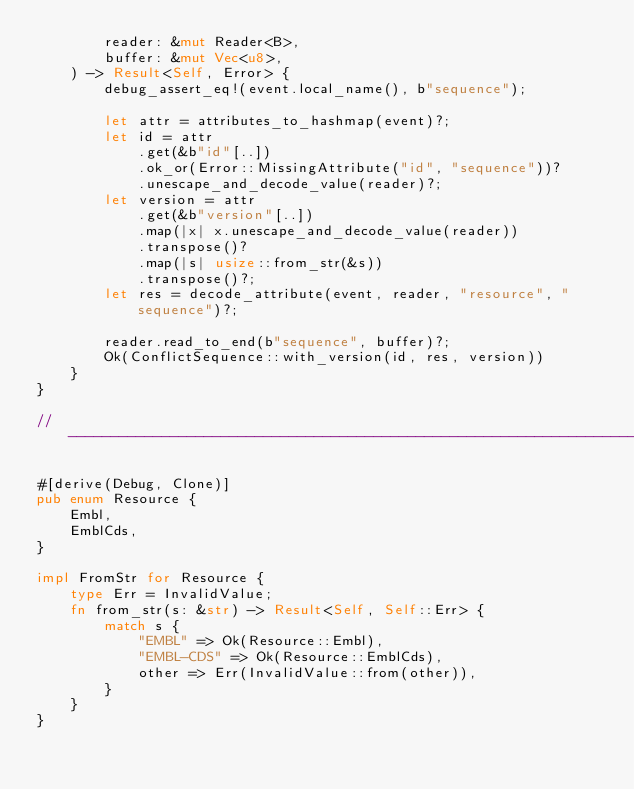Convert code to text. <code><loc_0><loc_0><loc_500><loc_500><_Rust_>        reader: &mut Reader<B>,
        buffer: &mut Vec<u8>,
    ) -> Result<Self, Error> {
        debug_assert_eq!(event.local_name(), b"sequence");

        let attr = attributes_to_hashmap(event)?;
        let id = attr
            .get(&b"id"[..])
            .ok_or(Error::MissingAttribute("id", "sequence"))?
            .unescape_and_decode_value(reader)?;
        let version = attr
            .get(&b"version"[..])
            .map(|x| x.unescape_and_decode_value(reader))
            .transpose()?
            .map(|s| usize::from_str(&s))
            .transpose()?;
        let res = decode_attribute(event, reader, "resource", "sequence")?;

        reader.read_to_end(b"sequence", buffer)?;
        Ok(ConflictSequence::with_version(id, res, version))
    }
}

// ---------------------------------------------------------------------------

#[derive(Debug, Clone)]
pub enum Resource {
    Embl,
    EmblCds,
}

impl FromStr for Resource {
    type Err = InvalidValue;
    fn from_str(s: &str) -> Result<Self, Self::Err> {
        match s {
            "EMBL" => Ok(Resource::Embl),
            "EMBL-CDS" => Ok(Resource::EmblCds),
            other => Err(InvalidValue::from(other)),
        }
    }
}
</code> 